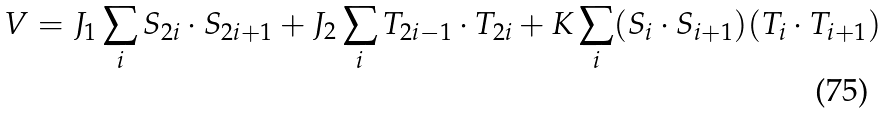Convert formula to latex. <formula><loc_0><loc_0><loc_500><loc_500>V = J _ { 1 } \sum _ { i } { S } _ { 2 i } \cdot { S } _ { 2 i + 1 } + J _ { 2 } \sum _ { i } { T } _ { 2 i - 1 } \cdot { T } _ { 2 i } + K \sum _ { i } ( { S } _ { i } \cdot { S } _ { i + 1 } ) ( { T } _ { i } \cdot { T } _ { i + 1 } )</formula> 